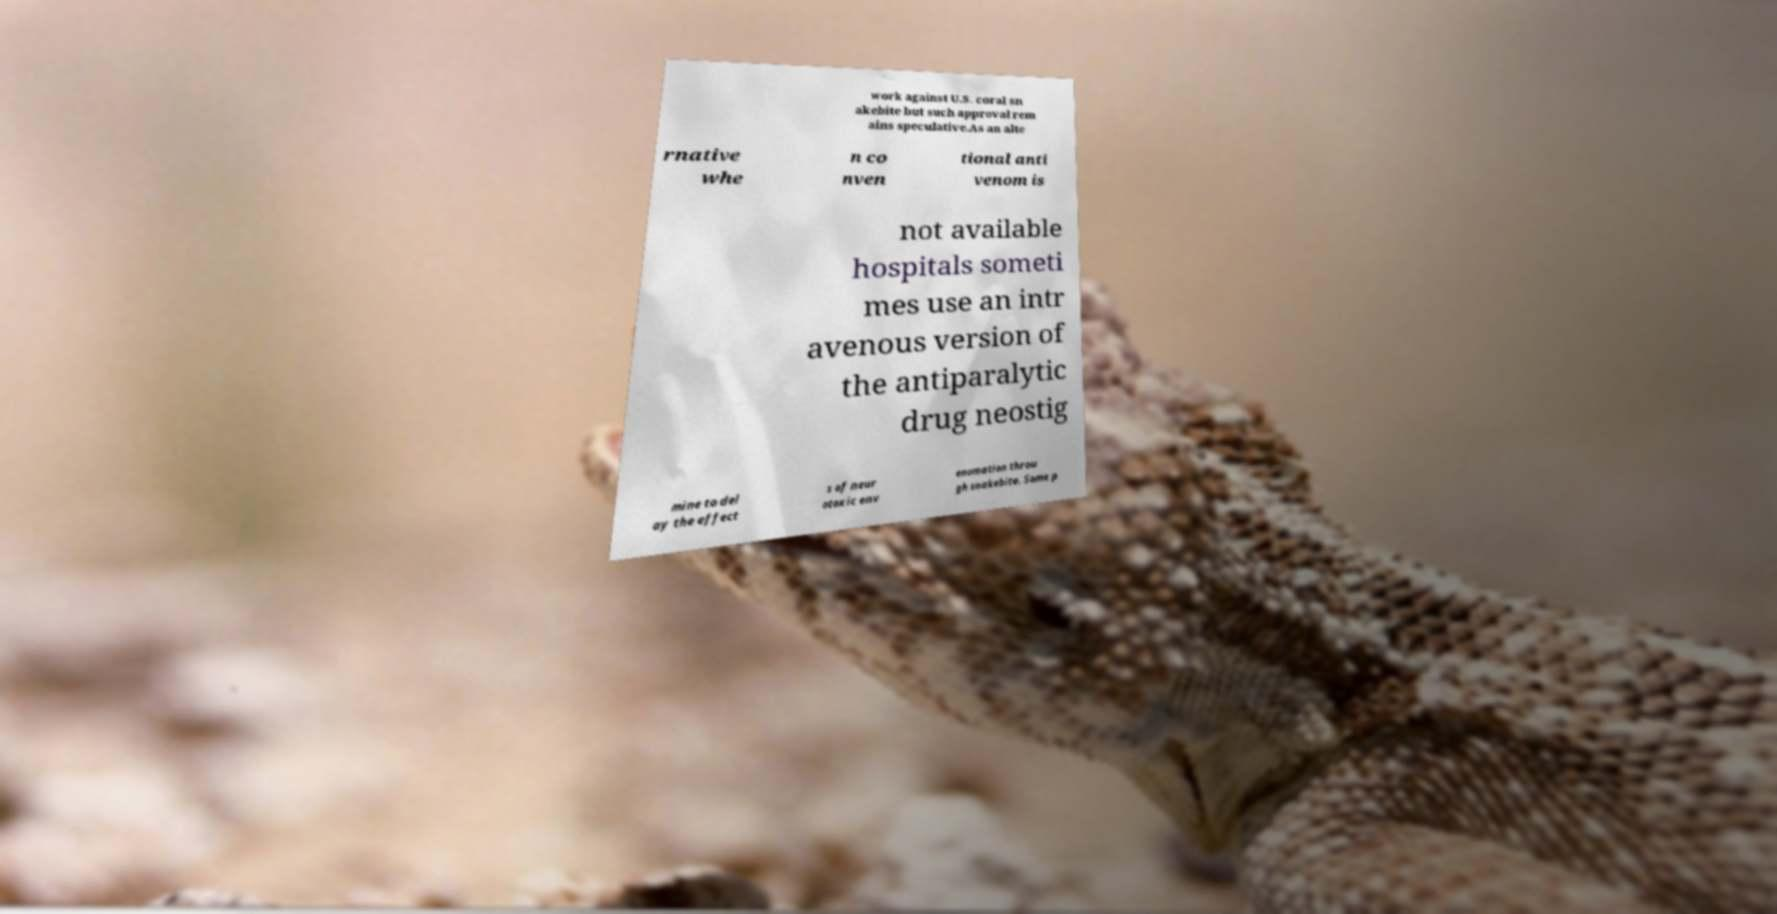For documentation purposes, I need the text within this image transcribed. Could you provide that? work against U.S. coral sn akebite but such approval rem ains speculative.As an alte rnative whe n co nven tional anti venom is not available hospitals someti mes use an intr avenous version of the antiparalytic drug neostig mine to del ay the effect s of neur otoxic env enomation throu gh snakebite. Some p 